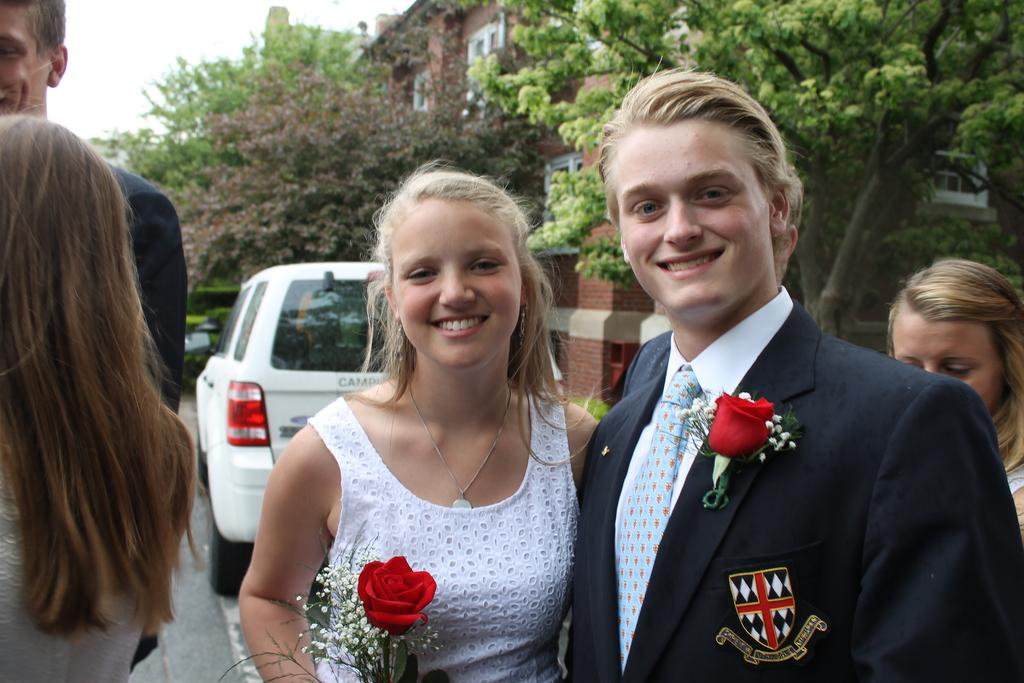What is happening in the image? There are people standing in the image. Can you describe the woman in the image? A woman is holding a rose in her hand. What can be seen in the background of the image? There are trees and a building in the background of the image. How would you describe the weather in the image? The sky is clear in the image, suggesting good weather. What type of nerve can be seen in the image? There is no nerve present in the image; it features people standing and a woman holding a rose. What time of day is depicted in the image? The provided facts do not give any information about the time of day, so it cannot be determined from the image. 